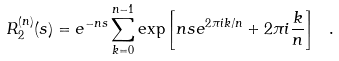Convert formula to latex. <formula><loc_0><loc_0><loc_500><loc_500>R _ { 2 } ^ { ( n ) } ( s ) = e ^ { - n s } \sum _ { k = 0 } ^ { n - 1 } \exp \left [ n s e ^ { 2 \pi i k / n } + 2 \pi i \frac { k } { n } \right ] \ .</formula> 